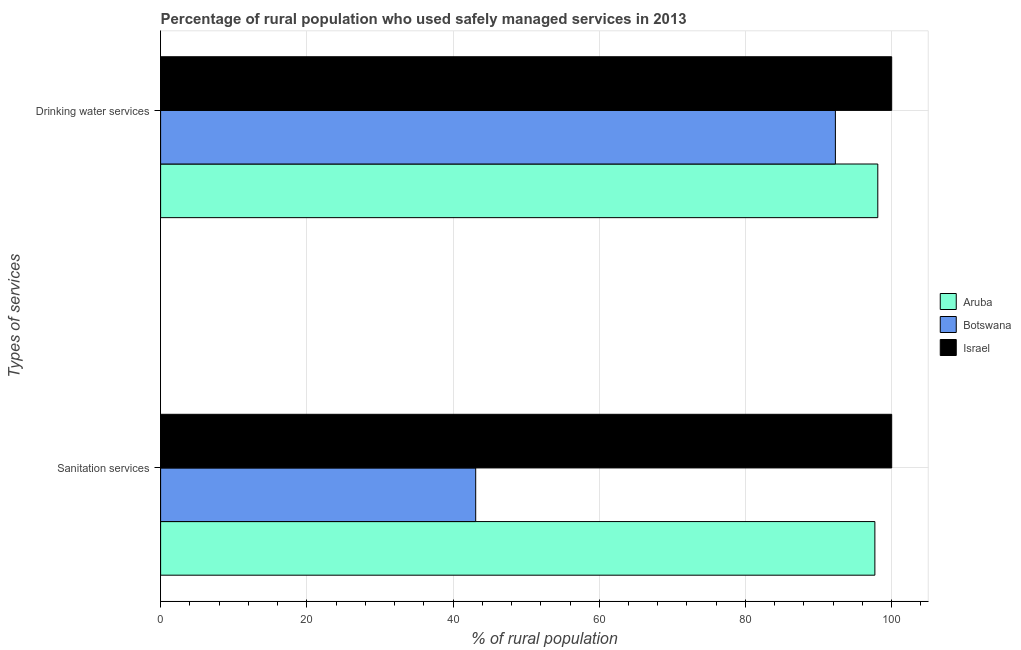How many groups of bars are there?
Ensure brevity in your answer.  2. Are the number of bars per tick equal to the number of legend labels?
Provide a succinct answer. Yes. Are the number of bars on each tick of the Y-axis equal?
Make the answer very short. Yes. What is the label of the 2nd group of bars from the top?
Ensure brevity in your answer.  Sanitation services. What is the percentage of rural population who used sanitation services in Aruba?
Offer a very short reply. 97.7. Across all countries, what is the maximum percentage of rural population who used drinking water services?
Offer a terse response. 100. Across all countries, what is the minimum percentage of rural population who used sanitation services?
Keep it short and to the point. 43.1. In which country was the percentage of rural population who used drinking water services maximum?
Your response must be concise. Israel. In which country was the percentage of rural population who used drinking water services minimum?
Give a very brief answer. Botswana. What is the total percentage of rural population who used drinking water services in the graph?
Ensure brevity in your answer.  290.4. What is the difference between the percentage of rural population who used sanitation services in Aruba and that in Botswana?
Provide a succinct answer. 54.6. What is the difference between the percentage of rural population who used drinking water services in Botswana and the percentage of rural population who used sanitation services in Israel?
Offer a very short reply. -7.7. What is the average percentage of rural population who used sanitation services per country?
Ensure brevity in your answer.  80.27. What is the difference between the percentage of rural population who used sanitation services and percentage of rural population who used drinking water services in Botswana?
Keep it short and to the point. -49.2. What is the ratio of the percentage of rural population who used sanitation services in Israel to that in Botswana?
Your answer should be compact. 2.32. What does the 3rd bar from the top in Sanitation services represents?
Make the answer very short. Aruba. What does the 1st bar from the bottom in Drinking water services represents?
Offer a very short reply. Aruba. How many bars are there?
Offer a terse response. 6. How many countries are there in the graph?
Offer a terse response. 3. Does the graph contain any zero values?
Offer a terse response. No. Does the graph contain grids?
Give a very brief answer. Yes. How many legend labels are there?
Give a very brief answer. 3. What is the title of the graph?
Offer a terse response. Percentage of rural population who used safely managed services in 2013. Does "Gabon" appear as one of the legend labels in the graph?
Your response must be concise. No. What is the label or title of the X-axis?
Make the answer very short. % of rural population. What is the label or title of the Y-axis?
Make the answer very short. Types of services. What is the % of rural population of Aruba in Sanitation services?
Your answer should be very brief. 97.7. What is the % of rural population in Botswana in Sanitation services?
Your answer should be very brief. 43.1. What is the % of rural population in Israel in Sanitation services?
Make the answer very short. 100. What is the % of rural population of Aruba in Drinking water services?
Ensure brevity in your answer.  98.1. What is the % of rural population of Botswana in Drinking water services?
Offer a very short reply. 92.3. Across all Types of services, what is the maximum % of rural population in Aruba?
Provide a short and direct response. 98.1. Across all Types of services, what is the maximum % of rural population in Botswana?
Offer a very short reply. 92.3. Across all Types of services, what is the maximum % of rural population in Israel?
Offer a very short reply. 100. Across all Types of services, what is the minimum % of rural population in Aruba?
Offer a terse response. 97.7. Across all Types of services, what is the minimum % of rural population in Botswana?
Give a very brief answer. 43.1. What is the total % of rural population in Aruba in the graph?
Your answer should be very brief. 195.8. What is the total % of rural population in Botswana in the graph?
Offer a terse response. 135.4. What is the difference between the % of rural population of Botswana in Sanitation services and that in Drinking water services?
Your answer should be compact. -49.2. What is the difference between the % of rural population in Aruba in Sanitation services and the % of rural population in Botswana in Drinking water services?
Provide a succinct answer. 5.4. What is the difference between the % of rural population of Aruba in Sanitation services and the % of rural population of Israel in Drinking water services?
Provide a succinct answer. -2.3. What is the difference between the % of rural population in Botswana in Sanitation services and the % of rural population in Israel in Drinking water services?
Keep it short and to the point. -56.9. What is the average % of rural population in Aruba per Types of services?
Your response must be concise. 97.9. What is the average % of rural population of Botswana per Types of services?
Your answer should be very brief. 67.7. What is the difference between the % of rural population in Aruba and % of rural population in Botswana in Sanitation services?
Your answer should be very brief. 54.6. What is the difference between the % of rural population in Aruba and % of rural population in Israel in Sanitation services?
Make the answer very short. -2.3. What is the difference between the % of rural population in Botswana and % of rural population in Israel in Sanitation services?
Your answer should be very brief. -56.9. What is the difference between the % of rural population in Aruba and % of rural population in Botswana in Drinking water services?
Provide a short and direct response. 5.8. What is the difference between the % of rural population in Aruba and % of rural population in Israel in Drinking water services?
Make the answer very short. -1.9. What is the ratio of the % of rural population in Botswana in Sanitation services to that in Drinking water services?
Keep it short and to the point. 0.47. What is the ratio of the % of rural population in Israel in Sanitation services to that in Drinking water services?
Ensure brevity in your answer.  1. What is the difference between the highest and the second highest % of rural population of Botswana?
Your response must be concise. 49.2. What is the difference between the highest and the lowest % of rural population of Aruba?
Provide a succinct answer. 0.4. What is the difference between the highest and the lowest % of rural population in Botswana?
Your response must be concise. 49.2. What is the difference between the highest and the lowest % of rural population of Israel?
Offer a very short reply. 0. 